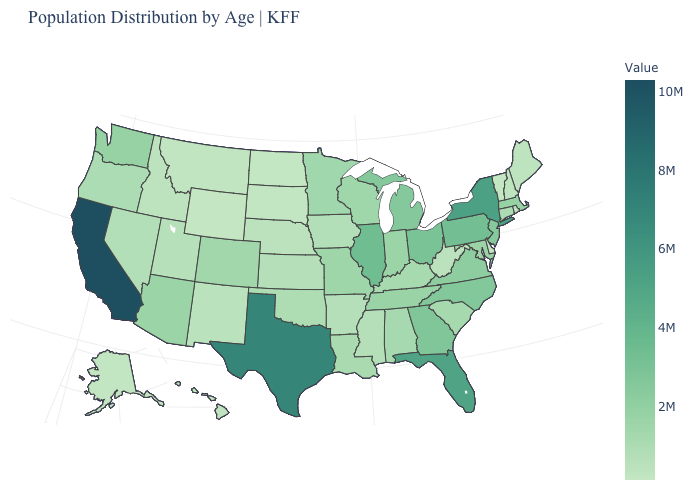Which states have the highest value in the USA?
Keep it brief. California. Does the map have missing data?
Write a very short answer. No. Does Alabama have a higher value than Florida?
Keep it brief. No. Which states have the lowest value in the MidWest?
Write a very short answer. North Dakota. Which states have the lowest value in the West?
Concise answer only. Wyoming. Does Vermont have the lowest value in the Northeast?
Short answer required. Yes. 